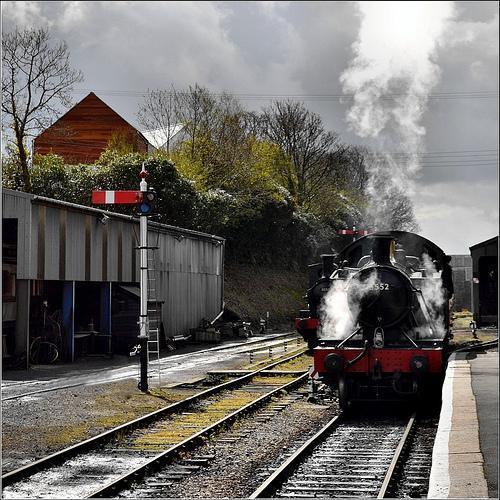How many trains are there?
Give a very brief answer. 1. 